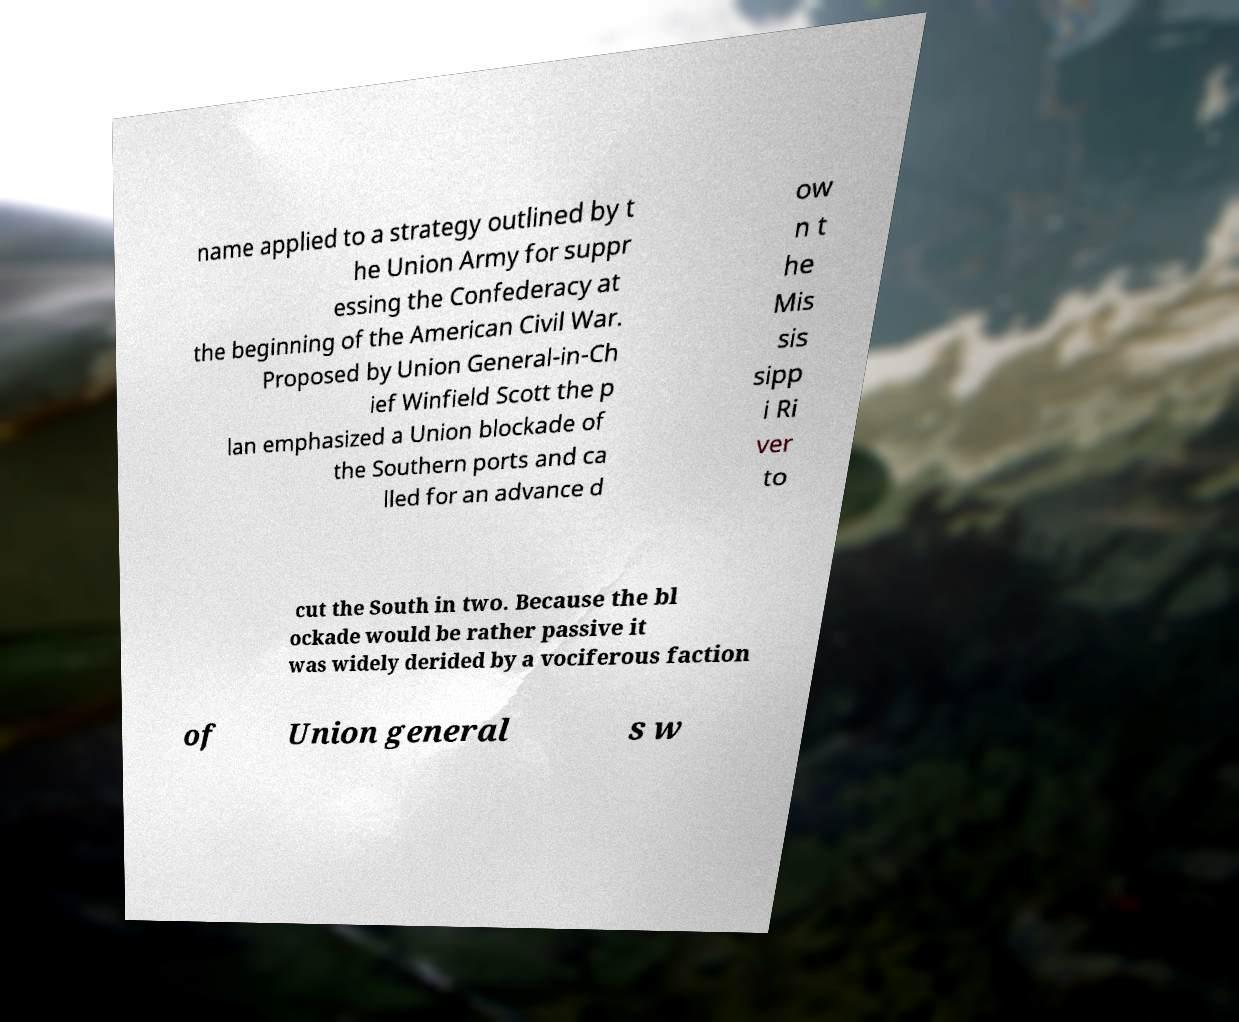I need the written content from this picture converted into text. Can you do that? name applied to a strategy outlined by t he Union Army for suppr essing the Confederacy at the beginning of the American Civil War. Proposed by Union General-in-Ch ief Winfield Scott the p lan emphasized a Union blockade of the Southern ports and ca lled for an advance d ow n t he Mis sis sipp i Ri ver to cut the South in two. Because the bl ockade would be rather passive it was widely derided by a vociferous faction of Union general s w 